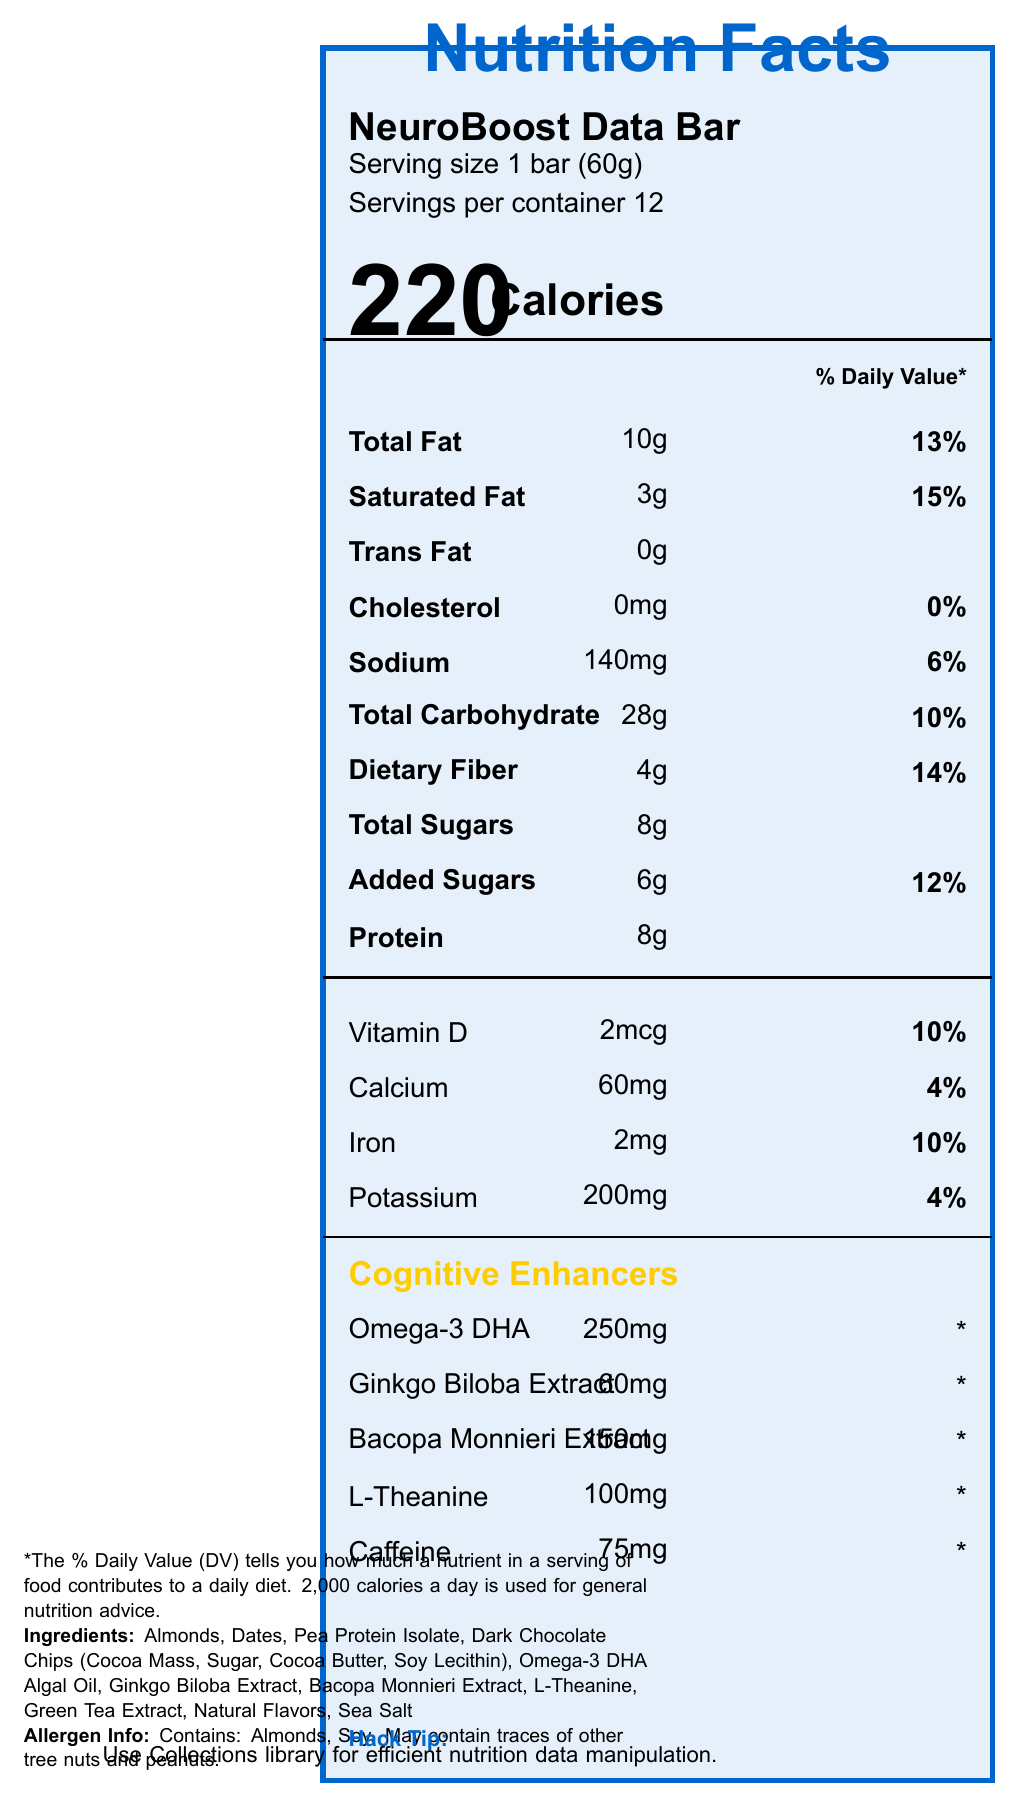what is the serving size for the NeuroBoost Data Bar? The serving size is stated at the beginning of the document under "Serving size 1 bar (60g)".
Answer: 1 bar (60g) how many calories are in one serving of NeuroBoost Data Bar? The number of calories is listed prominently in the middle of the document next to the large number 220.
Answer: 220 what percentage of the daily value is the total fat content? The daily value for total fat is listed as 13% next to the nutrient information for total fat.
Answer: 13% is there any trans fat in the NeuroBoost Data Bar? The document lists Trans Fat as 0g, indicating there is no trans fat.
Answer: No which cognitive enhancer has the highest quantity in the NeuroBoost Data Bar? The cognitive enhancers section shows the amount of each enhancer, with Omega-3 DHA having the highest quantity at 250mg.
Answer: Omega-3 DHA (250mg) how much added sugars are there per serving? The amount of added sugars is indicated as 6g in the nutrient information section.
Answer: 6g what are the potential allergens in the NeuroBoost Data Bar? The allergen information at the end of the document states that it contains Almonds and Soy.
Answer: Almonds, Soy which of the following vitamins or minerals is present in the highest daily value percentage? A. Vitamin D B. Calcium C. Iron D. Potassium Vitamin D has a daily value of 10%, which is higher than Calcium and Potassium at 4% and Iron at 10%, but Vitamin D comes first in the listing.
Answer: A how many servings are in one container? A. 6 B. 8 C. 10 D. 12 The document states that there are 12 servings per container.
Answer: D does the NeuroBoost Data Bar contain any cholesterol? The nutrient information lists cholesterol as 0mg with a daily value of 0%, indicating that there is no cholesterol.
Answer: No summarize the main idea of the document. The document is a comprehensive guide to the nutritional content of the NeuroBoost Data Bar, highlighting its nutrients, cognitive enhancers, ingredients, calorie content, and allergen information. It also includes a Hack tip related to data analysis.
Answer: The document provides detailed nutritional information for the NeuroBoost Data Bar, including serving size, calorie count, nutrient values, and cognitive enhancement ingredients. It also lists the ingredients and potential allergens while offering a tip about using the Hack programming language for data analysis. what is the daily value percentage of protein in the NeuroBoost Data Bar? The nutrient information provides the protein amount (8g) but does not specify the daily value percentage.
Answer: Not listed how much L-Theanine is present in the NeuroBoost Data Bar? The cognitive enhancers section lists L-Theanine as having 100mg.
Answer: 100mg what is the hack programming tip mentioned in the document? The document does mention a Hack Tip but does not detail the exact methods or constructs used, so the specific Hack programming tip cannot be determined.
Answer: Cannot be determined is the NeuroBoost Data Bar a good source of dietary fiber? The document lists dietary fiber as 4g, which is 14% of the daily value, indicating a significant amount of dietary fiber.
Answer: Yes is the potassium content higher than the sodium content in the NeuroBoost Data Bar? The potassium content is listed as 200mg, while the sodium content is 140mg. The potassium content is higher.
Answer: No 